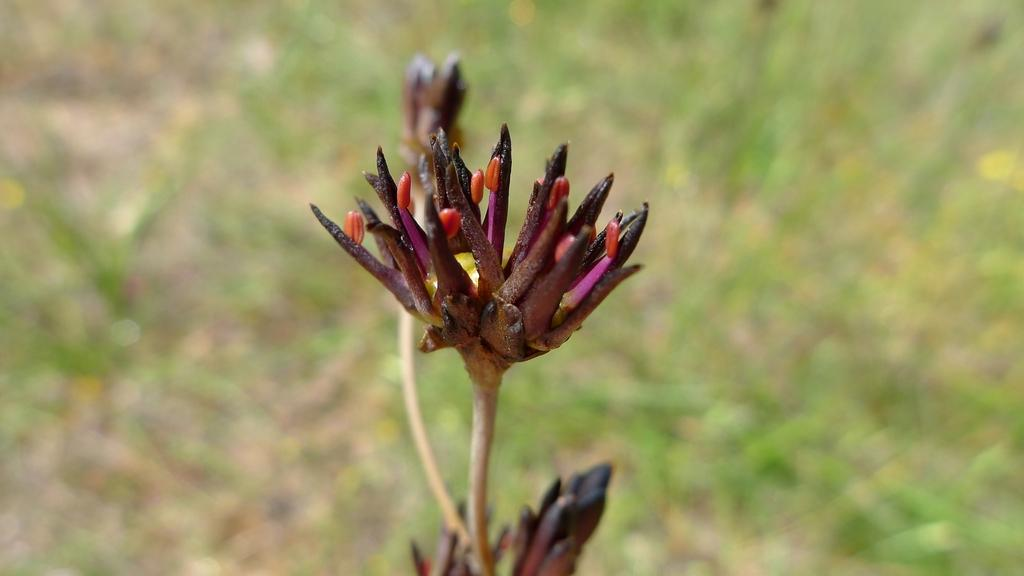What type of plant is visible in the image? There are flowers with stems in the image. Can you describe the plants in the background of the image? There are plants on the ground in the background of the image. What type of amusement can be seen in the image? There is no amusement present in the image; it features flowers and plants. What is being served for lunch in the image? There is no lunch being served in the image; it only shows flowers and plants. 